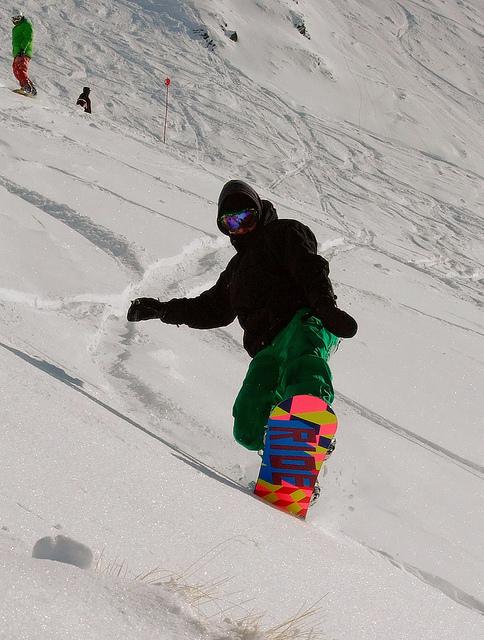What does the snowboard say?
Keep it brief. Ride. Is the man crashing?
Be succinct. No. Is the person going uphill or downhill?
Give a very brief answer. Downhill. 